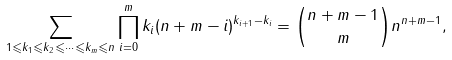<formula> <loc_0><loc_0><loc_500><loc_500>\sum _ { 1 \leqslant k _ { 1 } \leqslant k _ { 2 } \leqslant \cdots \leqslant k _ { m } \leqslant n } \prod _ { i = 0 } ^ { m } k _ { i } ( n + m - i ) ^ { k _ { i + 1 } - k _ { i } } = { n + m - 1 \choose m } n ^ { n + m - 1 } ,</formula> 